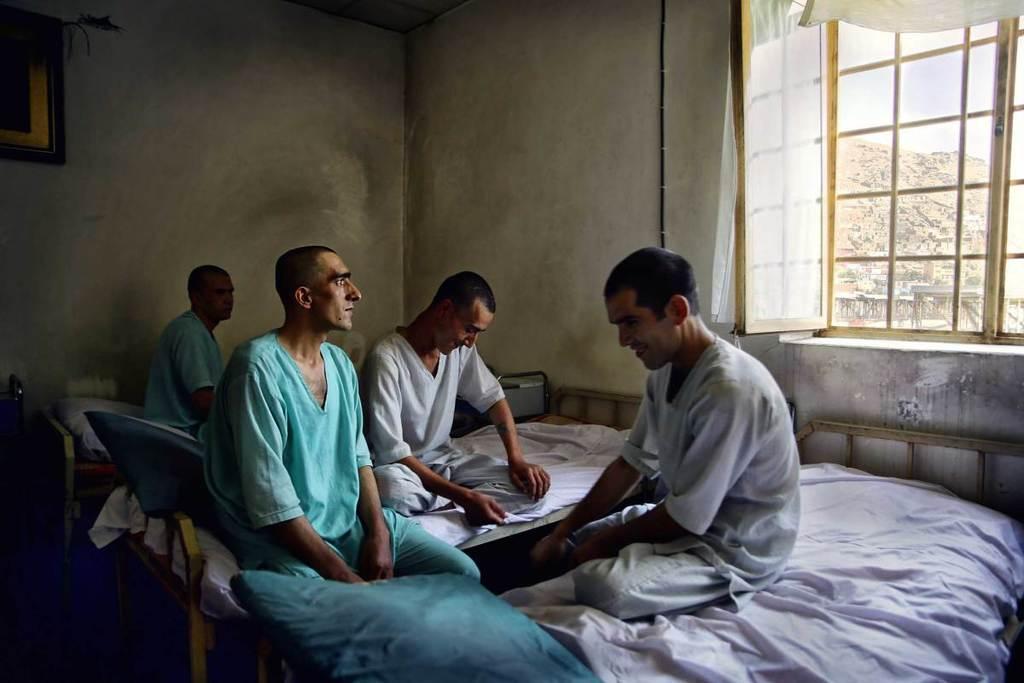Can you describe this image briefly? This picture is clicked inside the room. In the center we can see the group of persons sitting on the beds and we can see the pillows and some other objects. In the background we can see the wall, picture frame hanging on the wall and we can see the curtains and a window and through the window we can see the sky, rock and some other objects. 